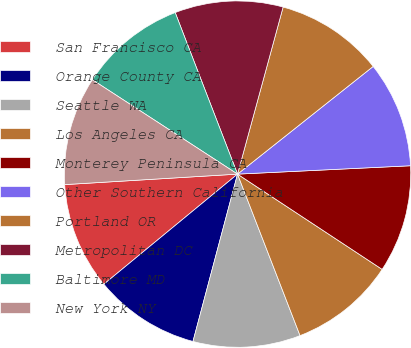Convert chart. <chart><loc_0><loc_0><loc_500><loc_500><pie_chart><fcel>San Francisco CA<fcel>Orange County CA<fcel>Seattle WA<fcel>Los Angeles CA<fcel>Monterey Peninsula CA<fcel>Other Southern California<fcel>Portland OR<fcel>Metropolitan DC<fcel>Baltimore MD<fcel>New York NY<nl><fcel>10.0%<fcel>9.89%<fcel>10.02%<fcel>9.85%<fcel>10.04%<fcel>9.91%<fcel>10.08%<fcel>10.1%<fcel>9.96%<fcel>10.14%<nl></chart> 